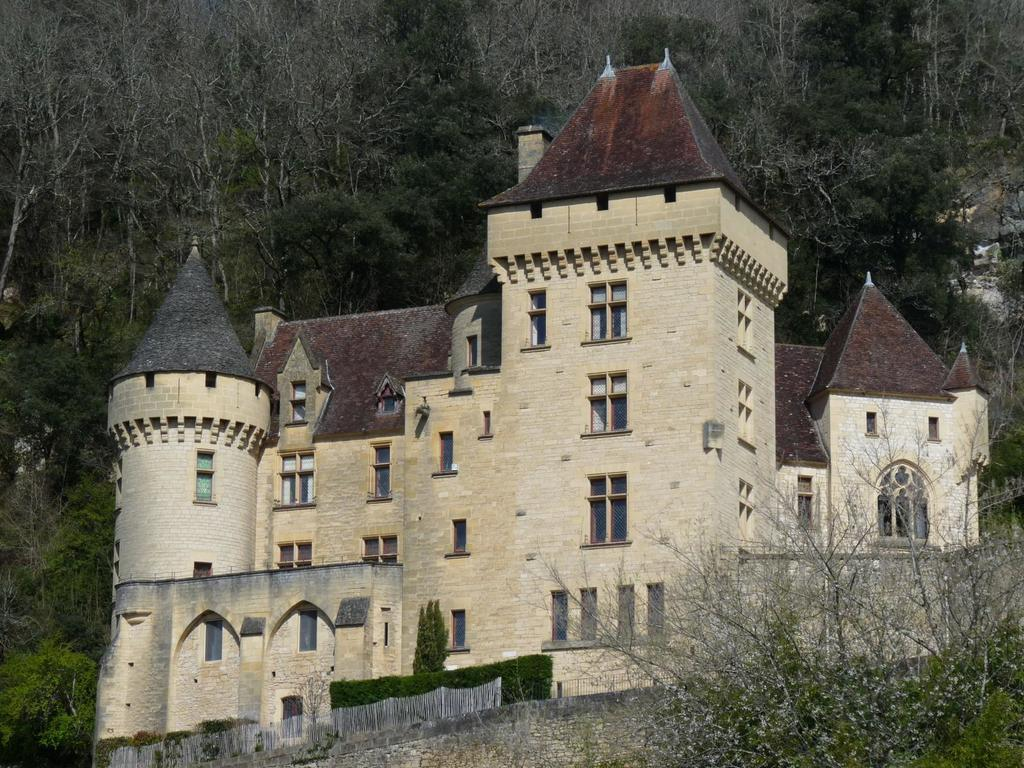What is the main subject in the center of the image? There is a castle in the center of the image. What can be seen in the background of the image? There are trees in the background of the image. What type of structure is present in the image? There is a wall in the image. Can you tell me how many crows are sitting on the castle in the image? There are no crows present in the image; it only features a castle, trees, and a wall. 